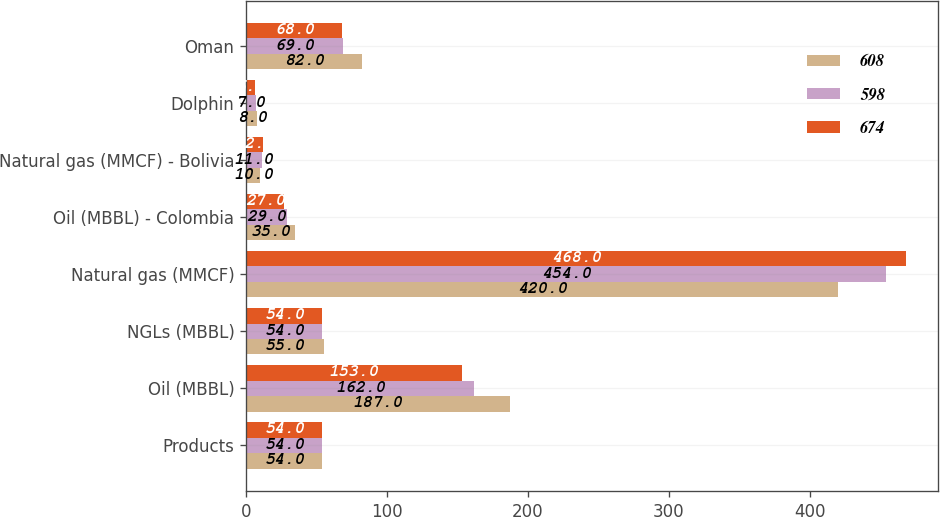Convert chart to OTSL. <chart><loc_0><loc_0><loc_500><loc_500><stacked_bar_chart><ecel><fcel>Products<fcel>Oil (MBBL)<fcel>NGLs (MBBL)<fcel>Natural gas (MMCF)<fcel>Oil (MBBL) - Colombia<fcel>Natural gas (MMCF) - Bolivia<fcel>Dolphin<fcel>Oman<nl><fcel>608<fcel>54<fcel>187<fcel>55<fcel>420<fcel>35<fcel>10<fcel>8<fcel>82<nl><fcel>598<fcel>54<fcel>162<fcel>54<fcel>454<fcel>29<fcel>11<fcel>7<fcel>69<nl><fcel>674<fcel>54<fcel>153<fcel>54<fcel>468<fcel>27<fcel>12<fcel>6<fcel>68<nl></chart> 